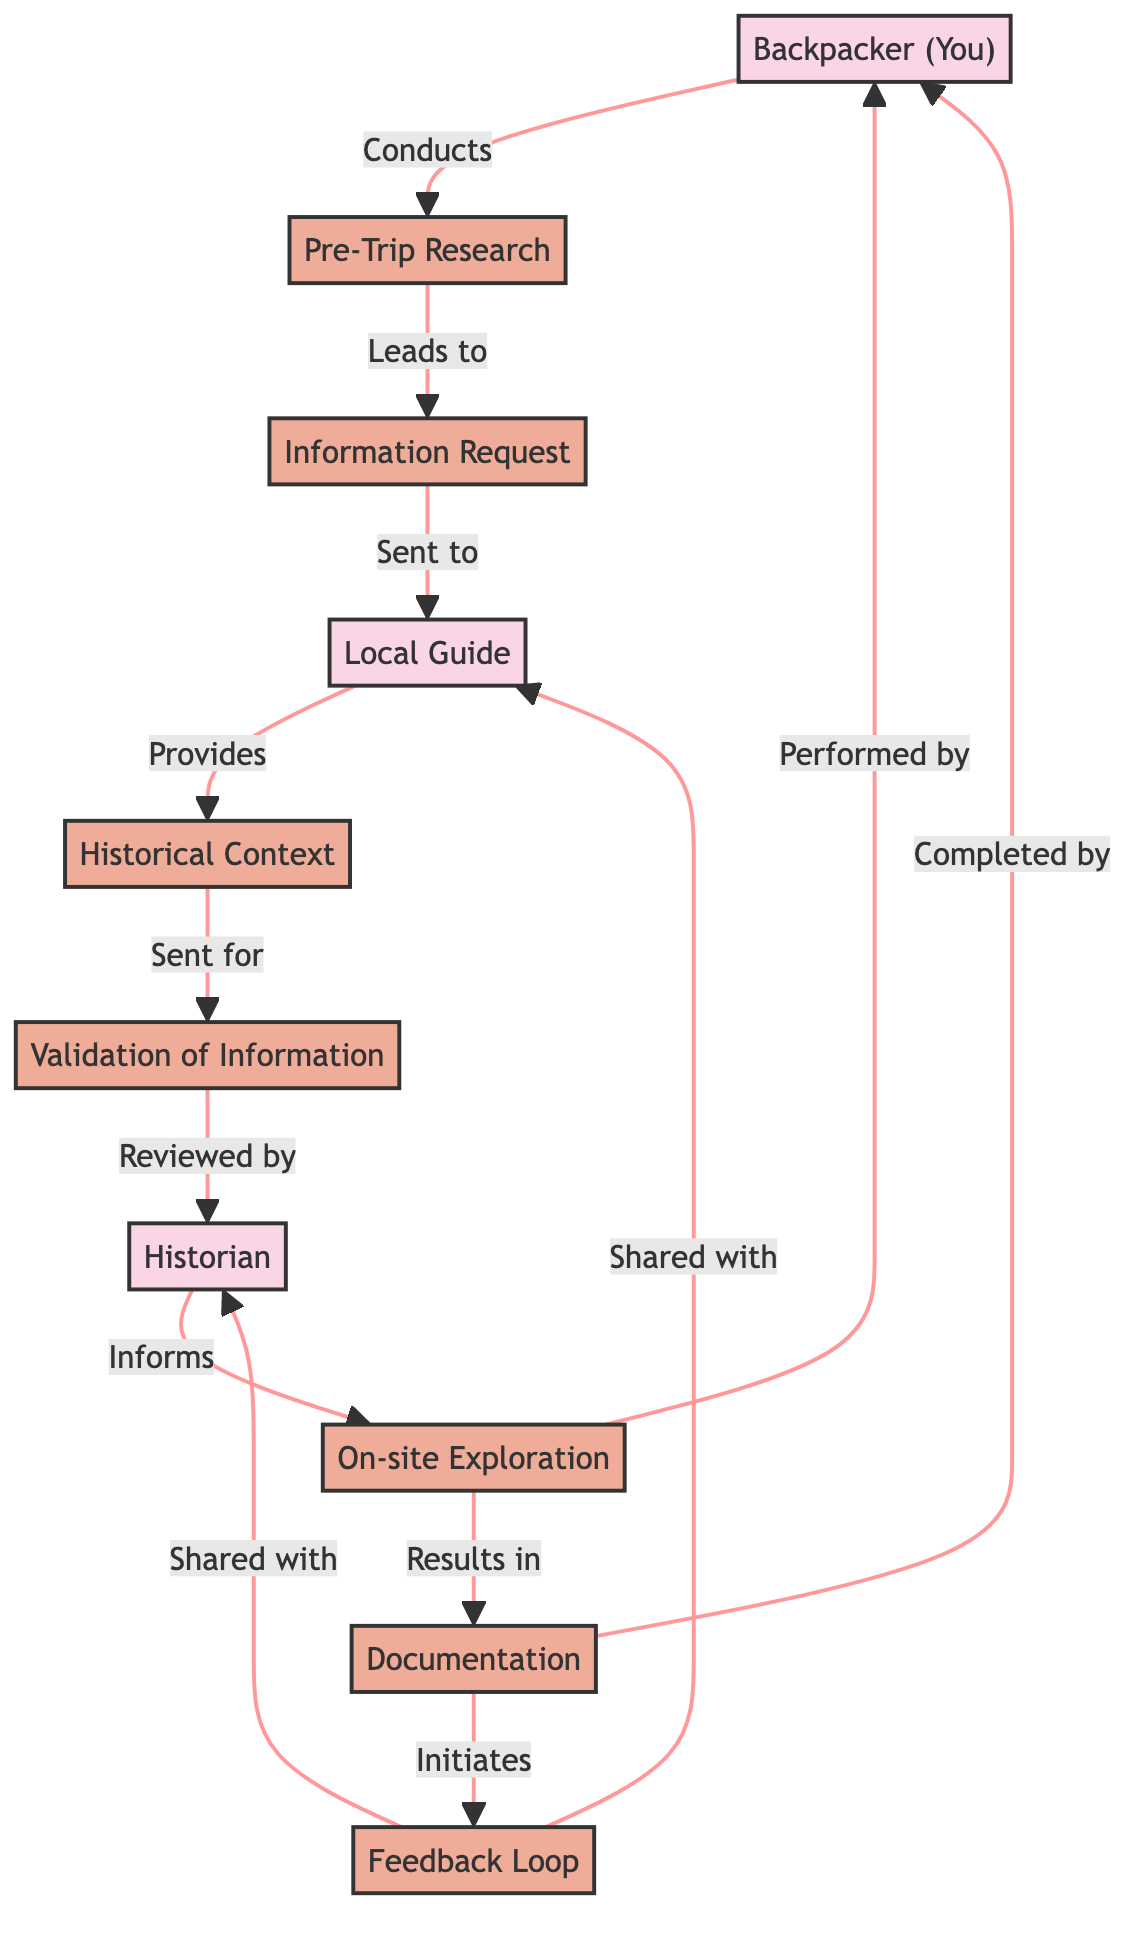What is the first process in the flow? The first process indicated in the flow chart is "Pre-Trip Research," which follows the backpacker's initial action of conducting research about mythological sites.
Answer: Pre-Trip Research How many actors are present in the diagram? The diagram displays three actors: the Backpacker, Local Guide, and Historian. This can be counted directly from the actor nodes in the flow chart.
Answer: 3 What does the Local Guide provide? The Local Guide provides "Historical Context Collection" which is mentioned as the information provided to the Backpacker after the information request.
Answer: Historical Context Collection Which process comes after the "Validation of Information"? After "Validation of Information," the next process is "On-site Exploration," which is indicated as the information flow following the historian's review.
Answer: On-site Exploration What is the purpose of the "Feedback Loop"? The purpose of the "Feedback Loop" is to allow the Backpacker to share feedback and additional findings with both the Local Guide and the Historian after completing the exploration and documentation.
Answer: Share feedback How many processes are listed in total? The total number of processes in the diagram is seven, including all steps from research to feedback. Each process can be counted from the process nodes present in the flow chart.
Answer: 7 Describe the relationship between the Backpacker and the Local Guide. The Backpacker requests information from the Local Guide, initiating a crucial communication flow which is a direct interaction leading to collection and validation of historical context.
Answer: Requests information Which actor validates the information? The actor who validates the information is the Historian, as indicated in the flow where validation follows after historical context collection provided by the Local Guide.
Answer: Historian What initiates the documentation process? The documentation process is initiated by the "On-site Exploration" performed by the Backpacker, indicating that exploration results in documenting findings.
Answer: On-site Exploration 